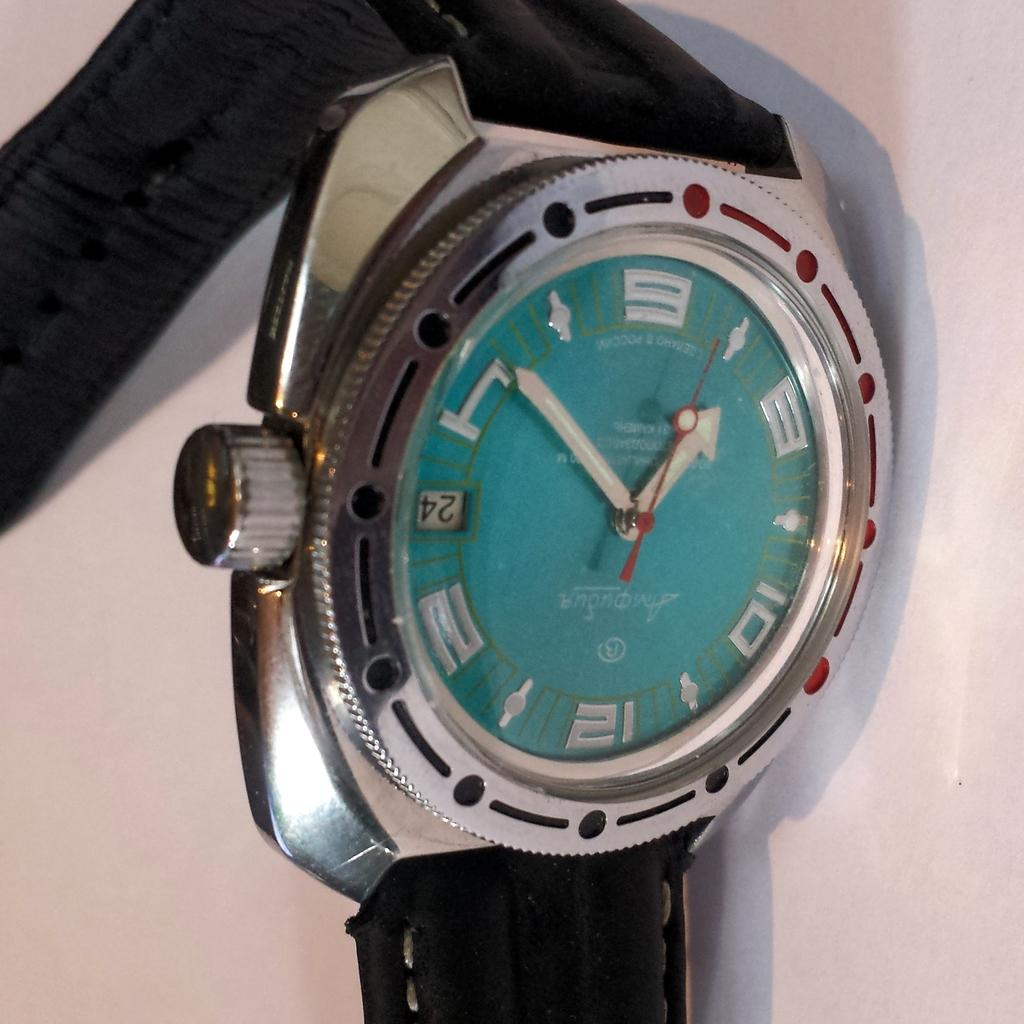Provide a one-sentence caption for the provided image. a metal and green watch shows the time is 1:50. 